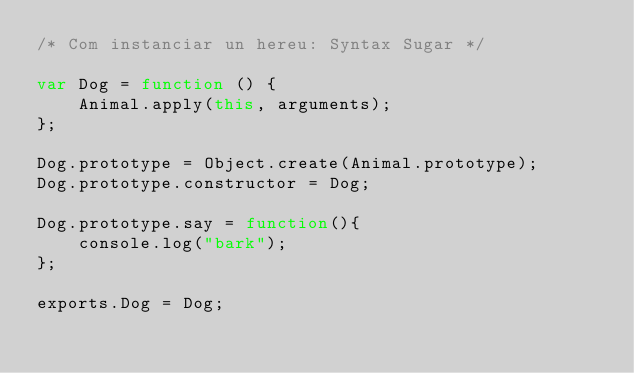Convert code to text. <code><loc_0><loc_0><loc_500><loc_500><_JavaScript_>/* Com instanciar un hereu: Syntax Sugar */

var Dog = function () {
    Animal.apply(this, arguments);
};

Dog.prototype = Object.create(Animal.prototype);
Dog.prototype.constructor = Dog;

Dog.prototype.say = function(){
    console.log("bark");
};

exports.Dog = Dog;</code> 